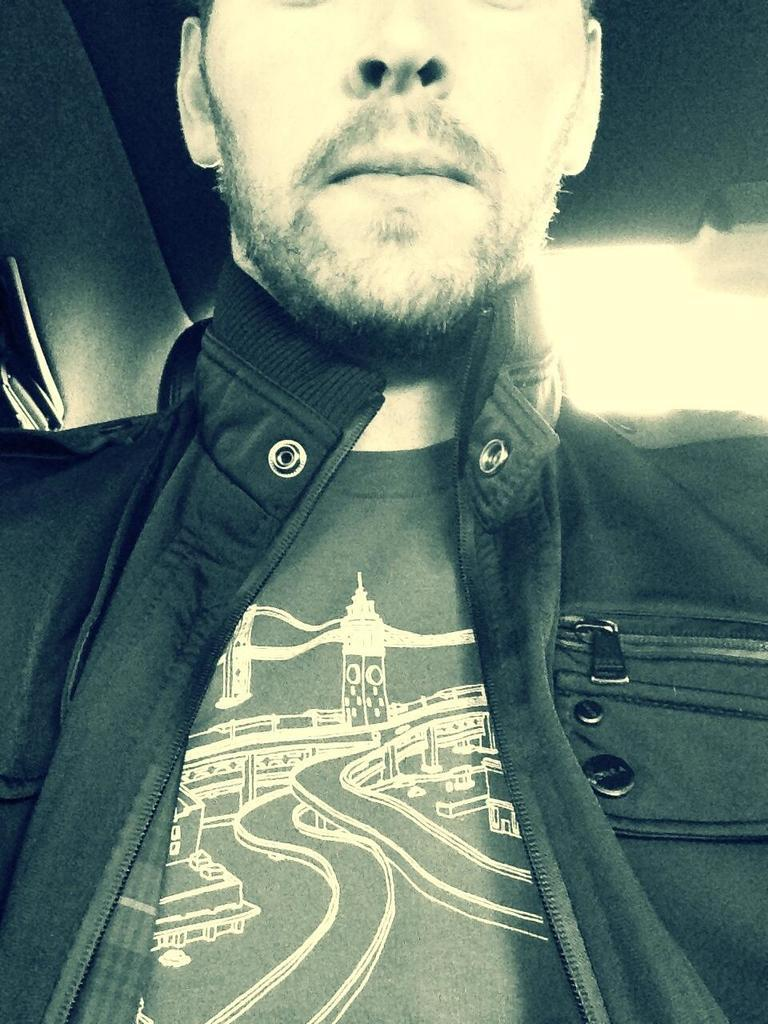What is present in the image? There is a person in the image. Can you describe the person's attire? The person is wearing clothes. What type of coil is being used to stir the sugar in the image? There is no coil or sugar present in the image; it only features a person wearing clothes. 